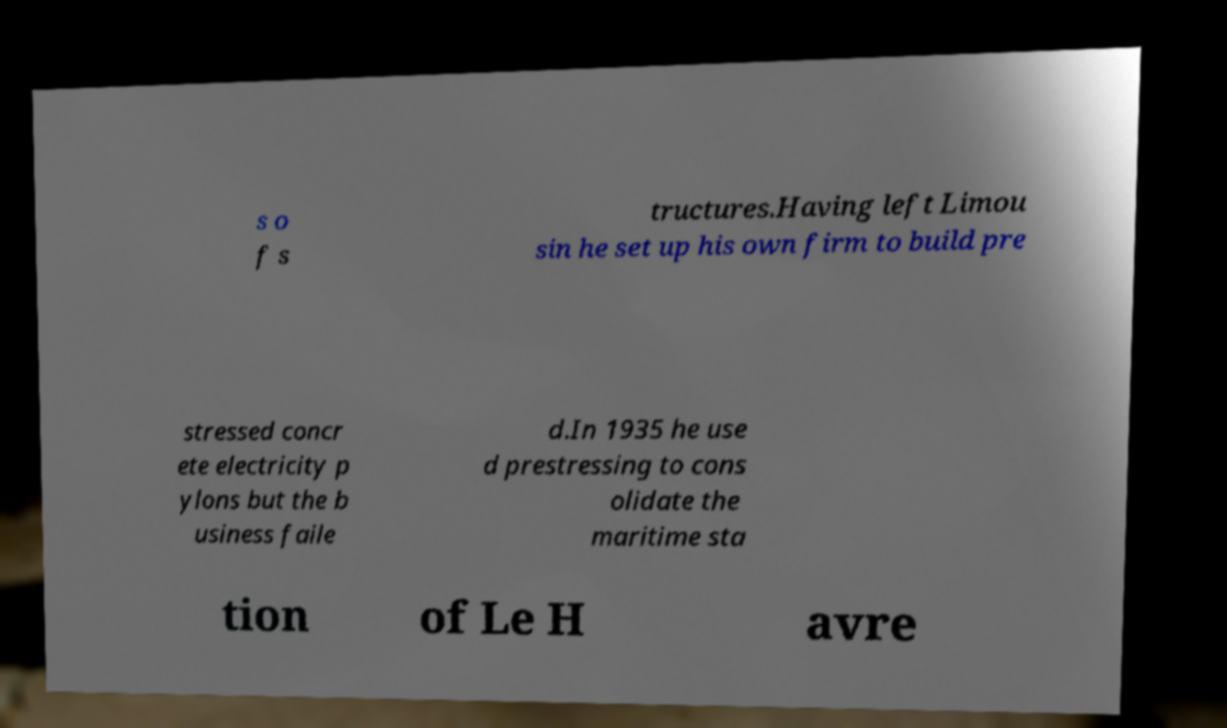I need the written content from this picture converted into text. Can you do that? s o f s tructures.Having left Limou sin he set up his own firm to build pre stressed concr ete electricity p ylons but the b usiness faile d.In 1935 he use d prestressing to cons olidate the maritime sta tion of Le H avre 